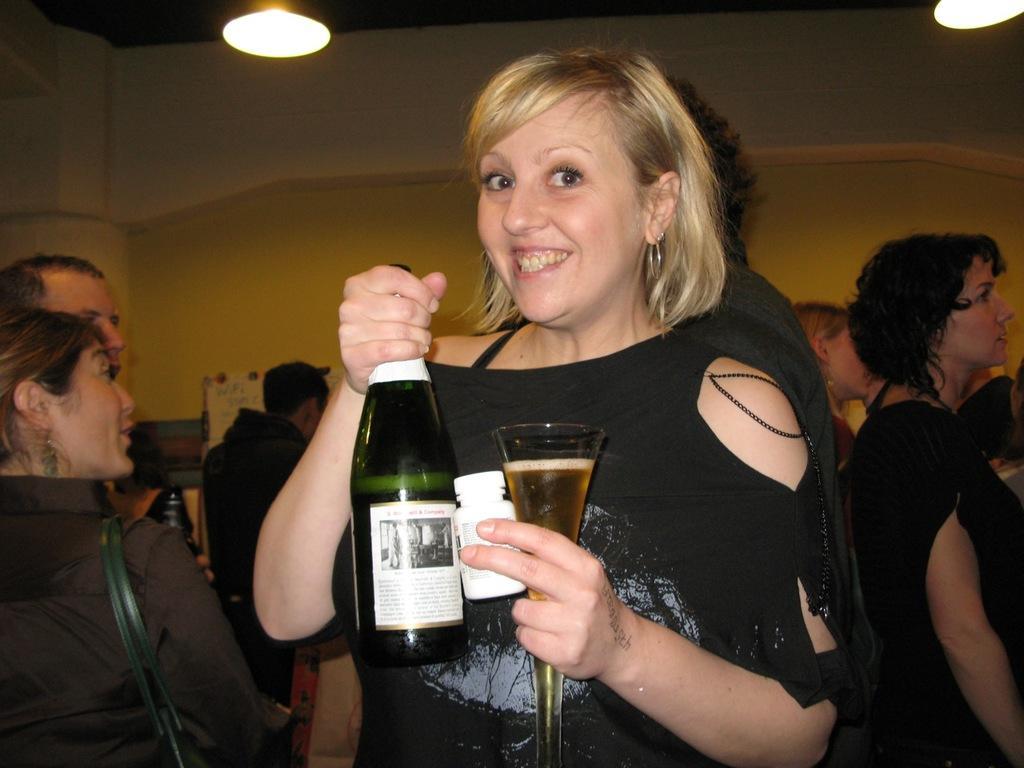In one or two sentences, can you explain what this image depicts? In this picture we can see a women who is holding a bottle, and a glass with her hands. She is smiling. Here we can see some persons. On the background there is a wall and this is light. 